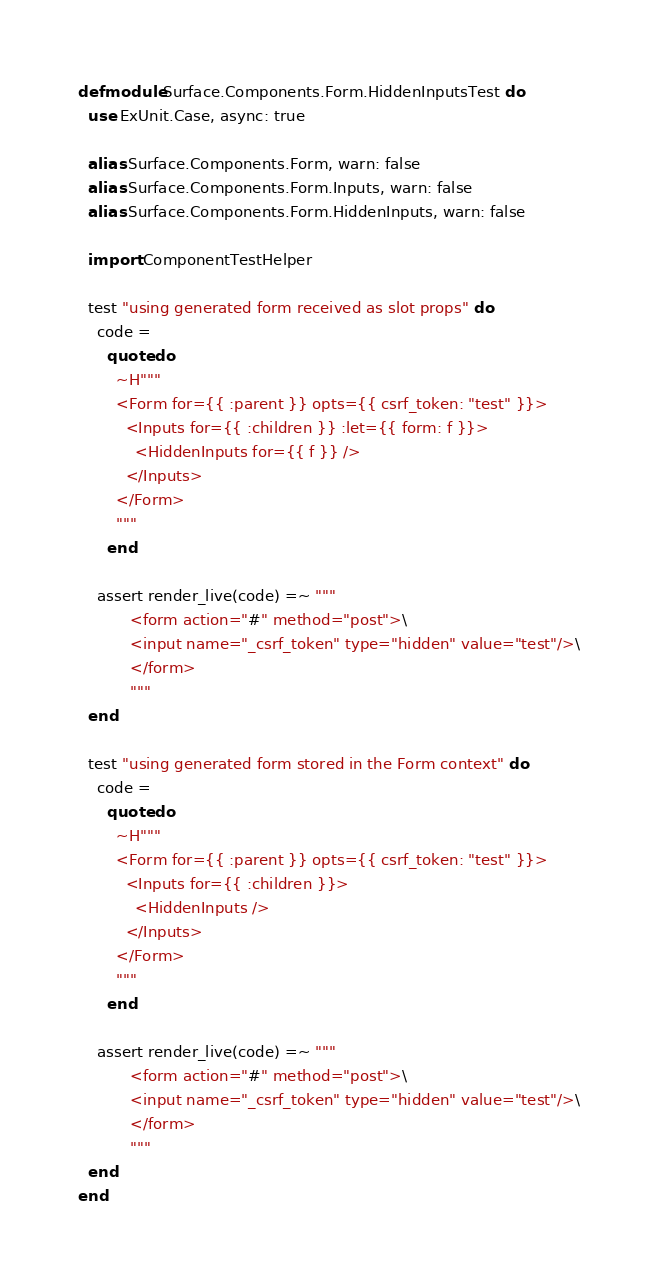Convert code to text. <code><loc_0><loc_0><loc_500><loc_500><_Elixir_>defmodule Surface.Components.Form.HiddenInputsTest do
  use ExUnit.Case, async: true

  alias Surface.Components.Form, warn: false
  alias Surface.Components.Form.Inputs, warn: false
  alias Surface.Components.Form.HiddenInputs, warn: false

  import ComponentTestHelper

  test "using generated form received as slot props" do
    code =
      quote do
        ~H"""
        <Form for={{ :parent }} opts={{ csrf_token: "test" }}>
          <Inputs for={{ :children }} :let={{ form: f }}>
            <HiddenInputs for={{ f }} />
          </Inputs>
        </Form>
        """
      end

    assert render_live(code) =~ """
           <form action="#" method="post">\
           <input name="_csrf_token" type="hidden" value="test"/>\
           </form>
           """
  end

  test "using generated form stored in the Form context" do
    code =
      quote do
        ~H"""
        <Form for={{ :parent }} opts={{ csrf_token: "test" }}>
          <Inputs for={{ :children }}>
            <HiddenInputs />
          </Inputs>
        </Form>
        """
      end

    assert render_live(code) =~ """
           <form action="#" method="post">\
           <input name="_csrf_token" type="hidden" value="test"/>\
           </form>
           """
  end
end
</code> 